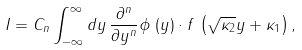Convert formula to latex. <formula><loc_0><loc_0><loc_500><loc_500>I = C _ { n } \int ^ { \infty } _ { - \infty } d y \, \frac { \partial ^ { n } } { \partial y ^ { n } } \phi \, \left ( y \right ) \cdot f \, \left ( \sqrt { \kappa _ { 2 } } y + \kappa _ { 1 } \right ) ,</formula> 